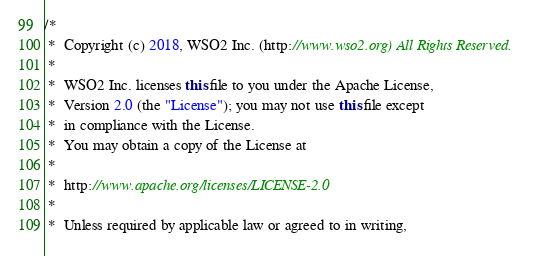Convert code to text. <code><loc_0><loc_0><loc_500><loc_500><_Java_>/*
 *  Copyright (c) 2018, WSO2 Inc. (http://www.wso2.org) All Rights Reserved.
 *
 *  WSO2 Inc. licenses this file to you under the Apache License,
 *  Version 2.0 (the "License"); you may not use this file except
 *  in compliance with the License.
 *  You may obtain a copy of the License at
 *
 *  http://www.apache.org/licenses/LICENSE-2.0
 *
 *  Unless required by applicable law or agreed to in writing,</code> 